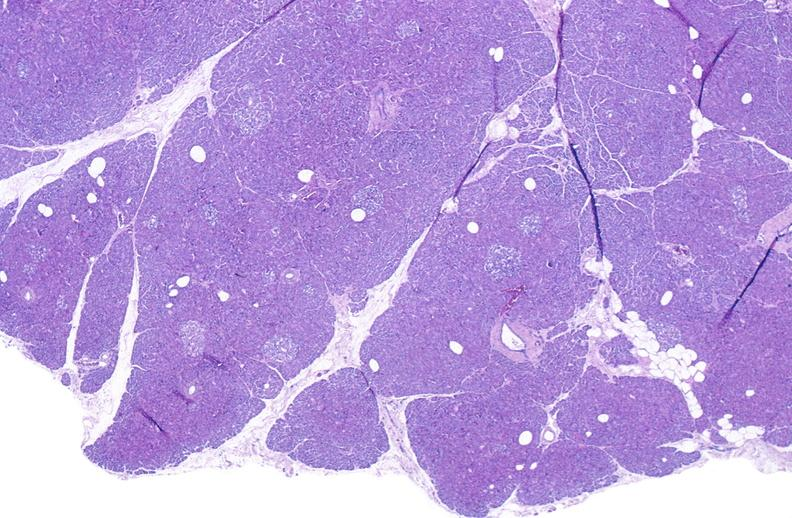where is this?
Answer the question using a single word or phrase. Pancreas 